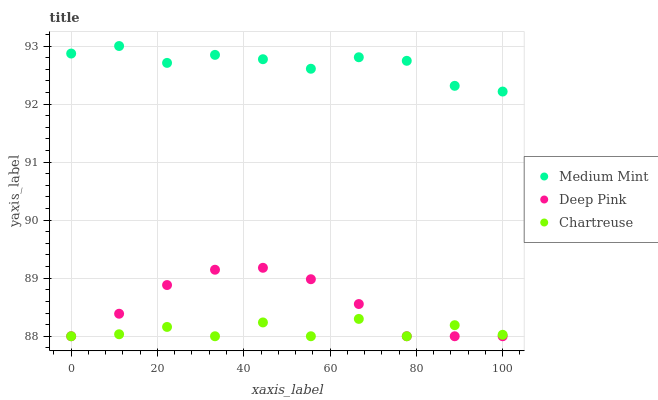Does Chartreuse have the minimum area under the curve?
Answer yes or no. Yes. Does Medium Mint have the maximum area under the curve?
Answer yes or no. Yes. Does Deep Pink have the minimum area under the curve?
Answer yes or no. No. Does Deep Pink have the maximum area under the curve?
Answer yes or no. No. Is Deep Pink the smoothest?
Answer yes or no. Yes. Is Chartreuse the roughest?
Answer yes or no. Yes. Is Chartreuse the smoothest?
Answer yes or no. No. Is Deep Pink the roughest?
Answer yes or no. No. Does Chartreuse have the lowest value?
Answer yes or no. Yes. Does Medium Mint have the highest value?
Answer yes or no. Yes. Does Deep Pink have the highest value?
Answer yes or no. No. Is Chartreuse less than Medium Mint?
Answer yes or no. Yes. Is Medium Mint greater than Chartreuse?
Answer yes or no. Yes. Does Chartreuse intersect Deep Pink?
Answer yes or no. Yes. Is Chartreuse less than Deep Pink?
Answer yes or no. No. Is Chartreuse greater than Deep Pink?
Answer yes or no. No. Does Chartreuse intersect Medium Mint?
Answer yes or no. No. 